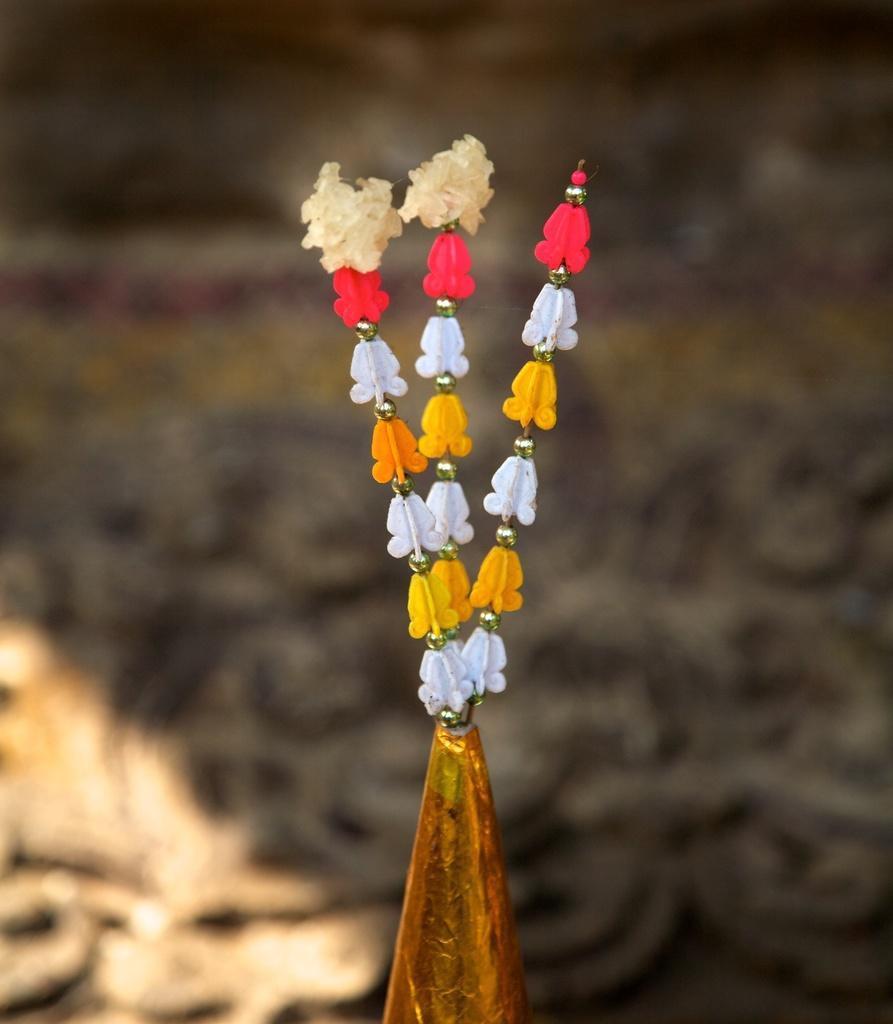In one or two sentences, can you explain what this image depicts? In this image I can see an object in multi color and I can see blurred background. 